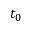Convert formula to latex. <formula><loc_0><loc_0><loc_500><loc_500>t _ { 0 }</formula> 